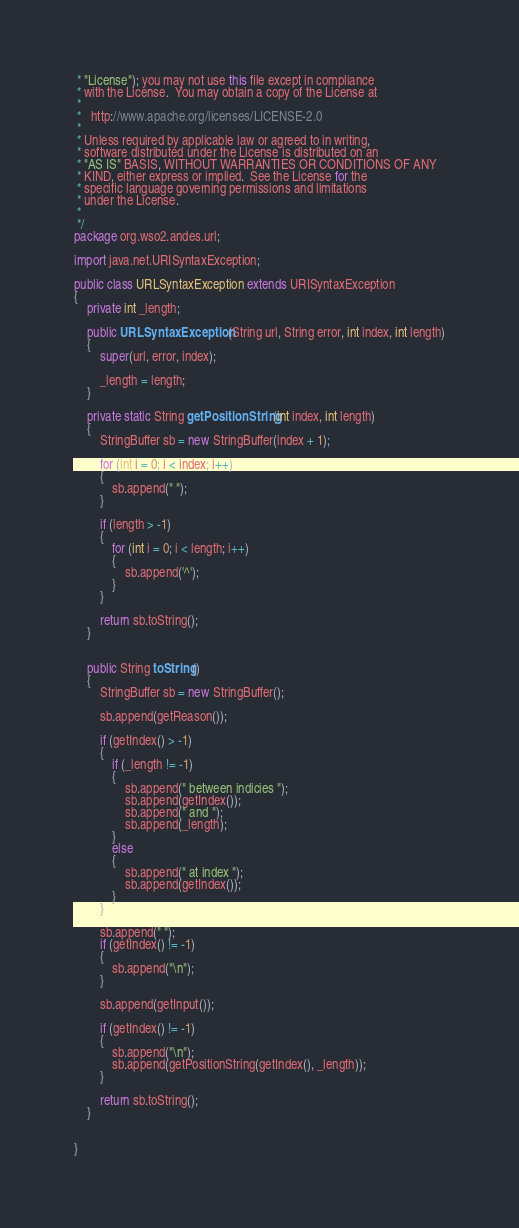<code> <loc_0><loc_0><loc_500><loc_500><_Java_> * "License"); you may not use this file except in compliance
 * with the License.  You may obtain a copy of the License at
 * 
 *   http://www.apache.org/licenses/LICENSE-2.0
 * 
 * Unless required by applicable law or agreed to in writing,
 * software distributed under the License is distributed on an
 * "AS IS" BASIS, WITHOUT WARRANTIES OR CONDITIONS OF ANY
 * KIND, either express or implied.  See the License for the
 * specific language governing permissions and limitations
 * under the License.
 *
 */
package org.wso2.andes.url;

import java.net.URISyntaxException;

public class URLSyntaxException extends URISyntaxException
{
    private int _length;

    public URLSyntaxException(String url, String error, int index, int length)
    {
        super(url, error, index);

        _length = length;
    }

    private static String getPositionString(int index, int length)
    {
        StringBuffer sb = new StringBuffer(index + 1);

        for (int i = 0; i < index; i++)
        {
            sb.append(" ");
        }

        if (length > -1)
        {
            for (int i = 0; i < length; i++)
            {
                sb.append('^');
            }
        }

        return sb.toString();
    }


    public String toString()
    {
        StringBuffer sb = new StringBuffer();

        sb.append(getReason());

        if (getIndex() > -1)
        {
            if (_length != -1)
            {
                sb.append(" between indicies ");
                sb.append(getIndex());
                sb.append(" and ");
                sb.append(_length);
            }
            else
            {
                sb.append(" at index ");
                sb.append(getIndex());
            }
        }

        sb.append(" ");
        if (getIndex() != -1)
        {
            sb.append("\n");
        }

        sb.append(getInput());

        if (getIndex() != -1)
        {
            sb.append("\n");
            sb.append(getPositionString(getIndex(), _length));
        }

        return sb.toString();
    }


}
</code> 